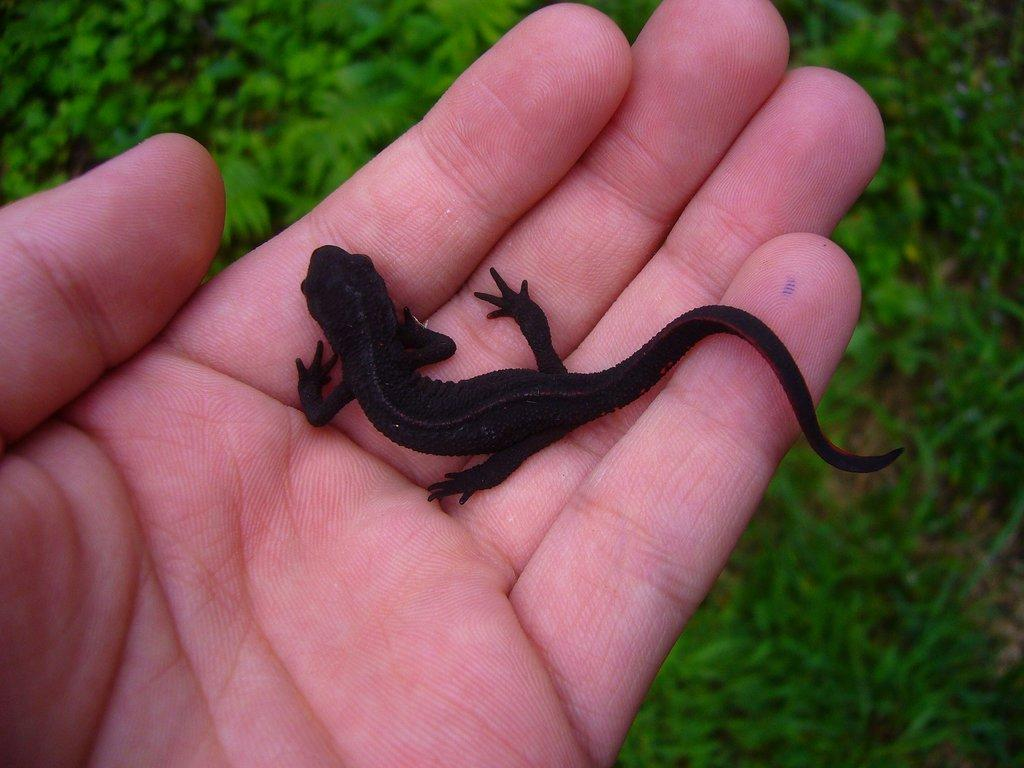What type of animal is in the image? There is a reptile in the image. How is the reptile being held or supported in the image? The reptile is on the hand of a person. What type of natural environment is visible in the image? Some grass is visible on the ground in the image. What type of nerve can be seen in the image? There is no nerve visible in the image; it features a reptile on a person's hand and grass on the ground. 